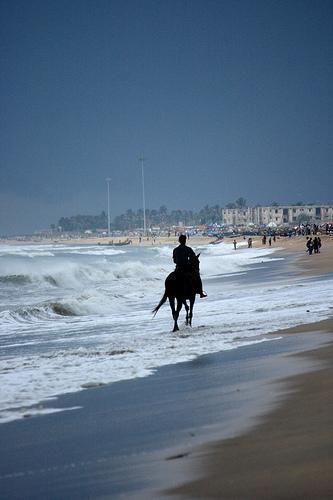How many people are riding horses?
Give a very brief answer. 1. 